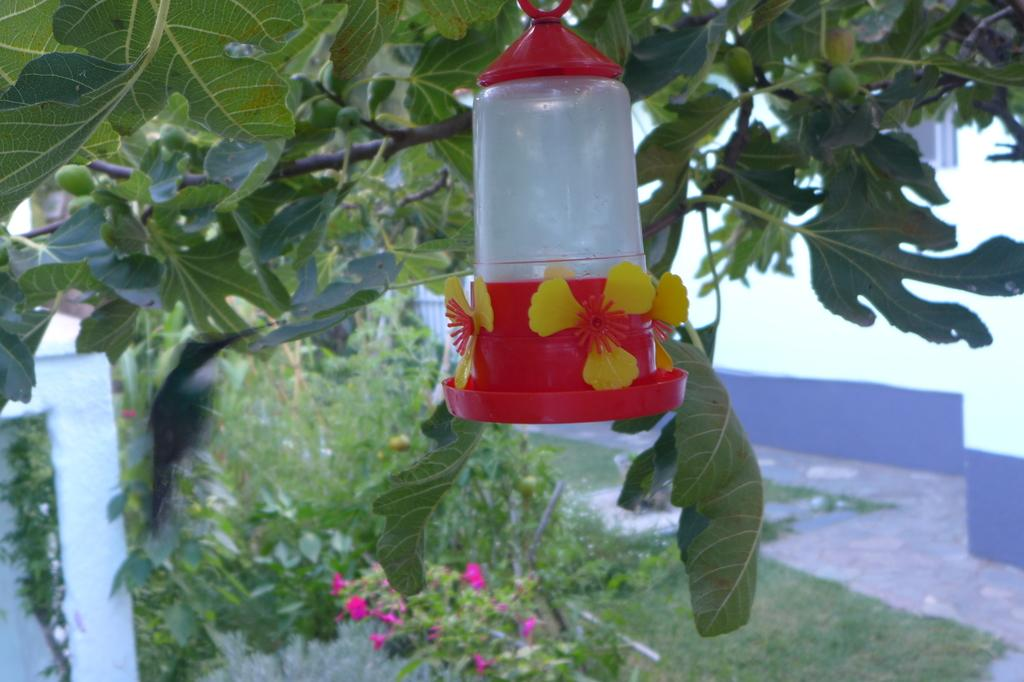What color is the prominent object in the image? There is a red color object in the image. What is located next to the red object? There is a tree beside the red object. What can be seen in the background of the image? There are plants in the background of the image. What type of shop can be seen in the image? There is no shop present in the image. What is the tin used for in the image? There is no tin present in the image. 